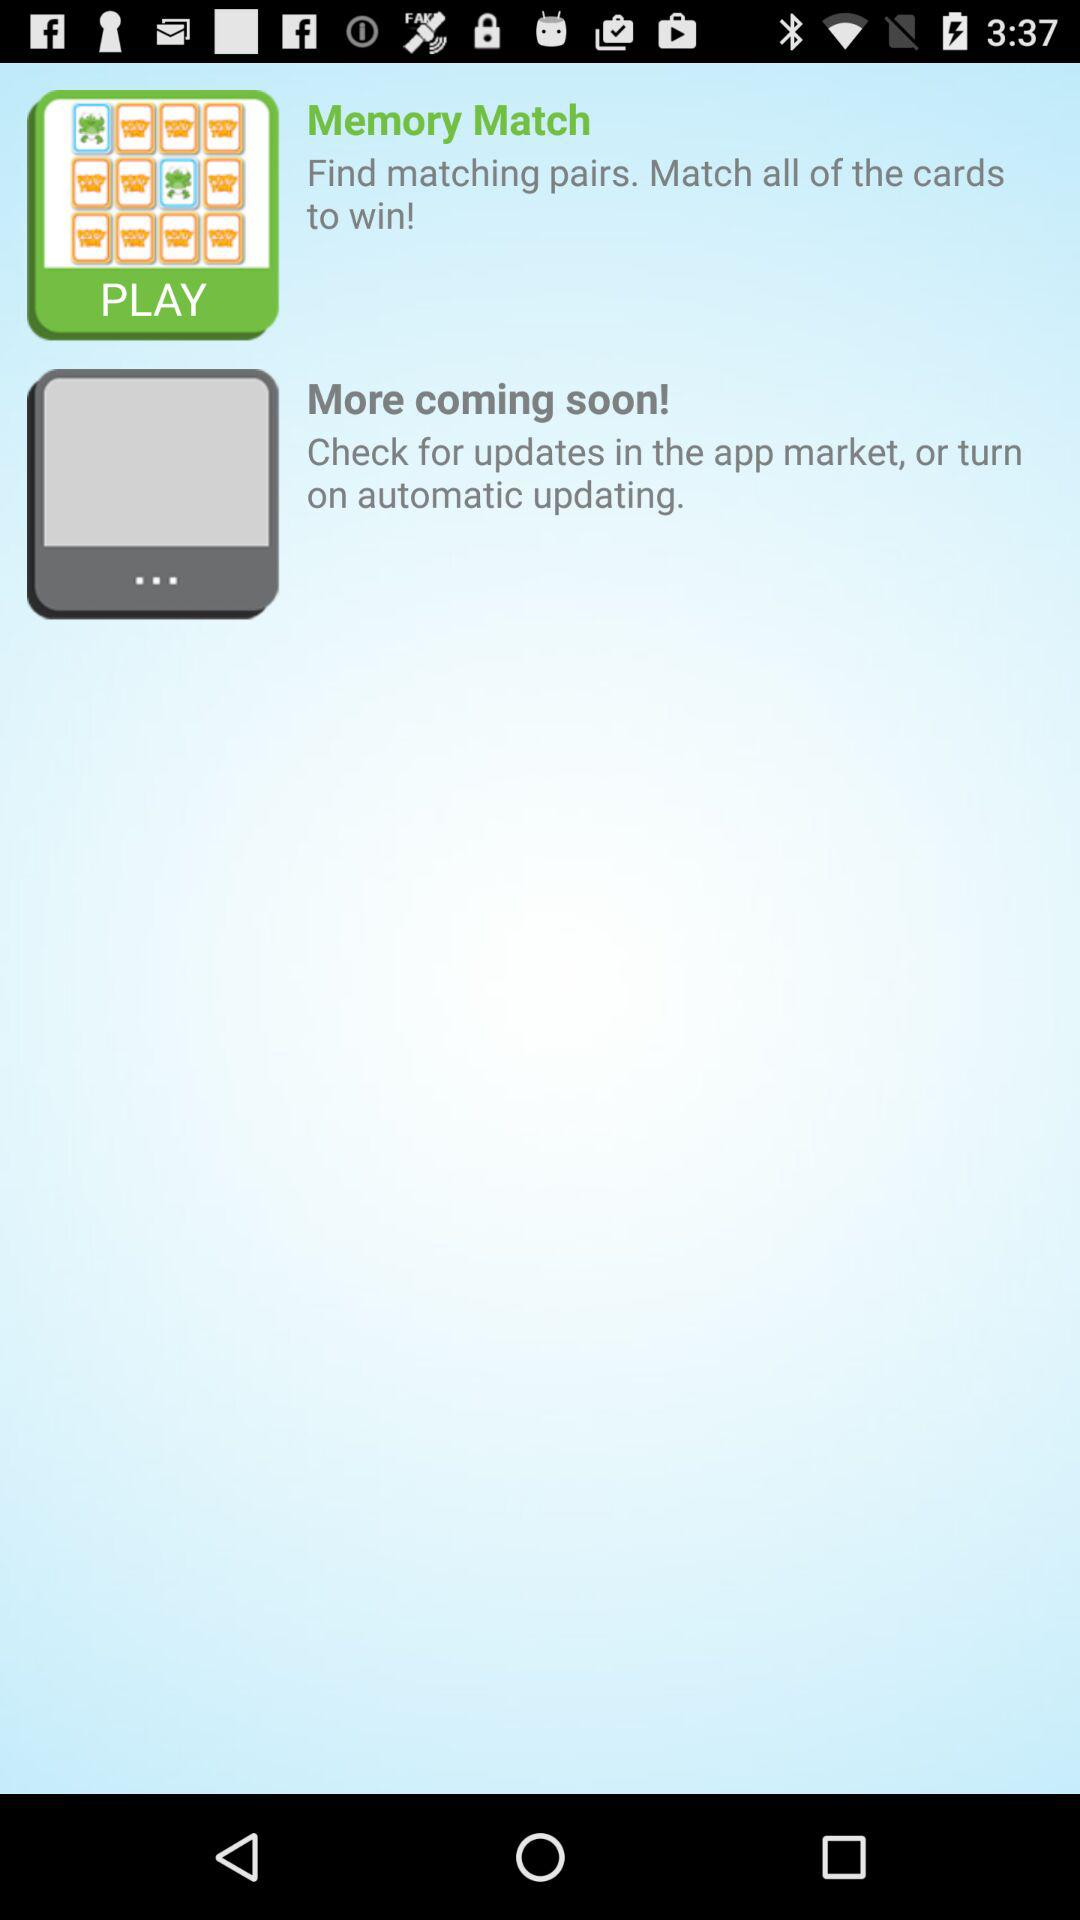What is the name of the game shown? The name of the game shown is Memory Match. 